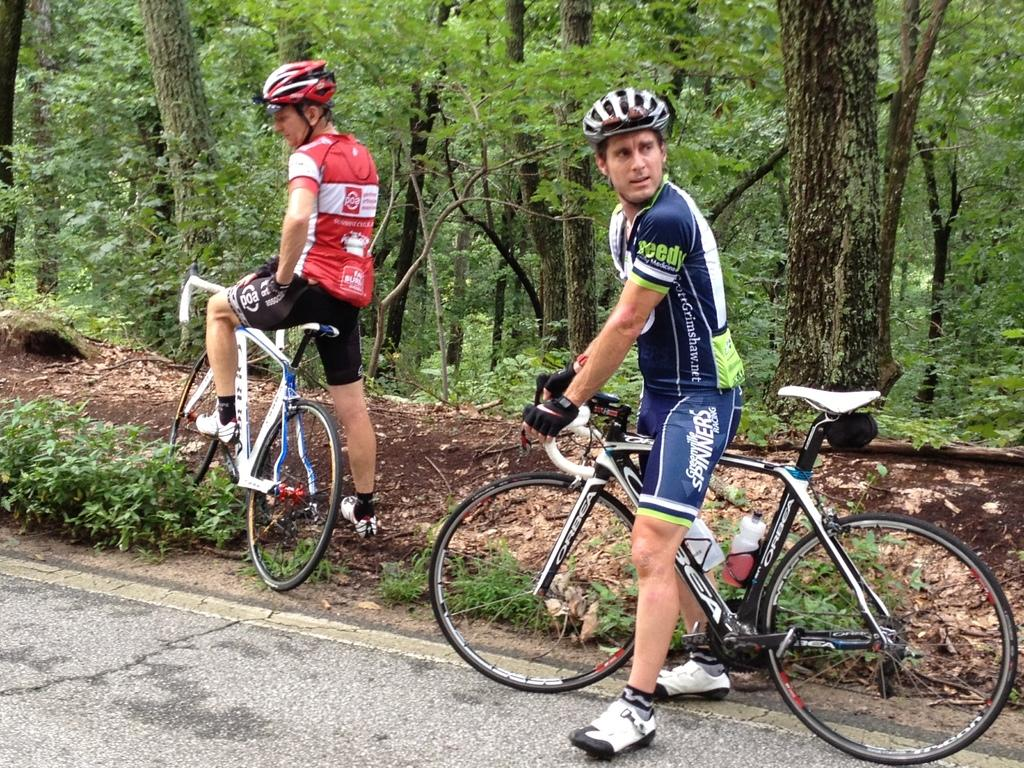What can be seen in the image? There are men in the image. image. What are the men doing in the image? The men are standing and holding bicycles. What can be seen in the background of the image? There are trees visible in the background of the image. What type of rock can be seen in the image? There is no rock present in the image. What type of road can be seen in the image? There is no road present in the image. 